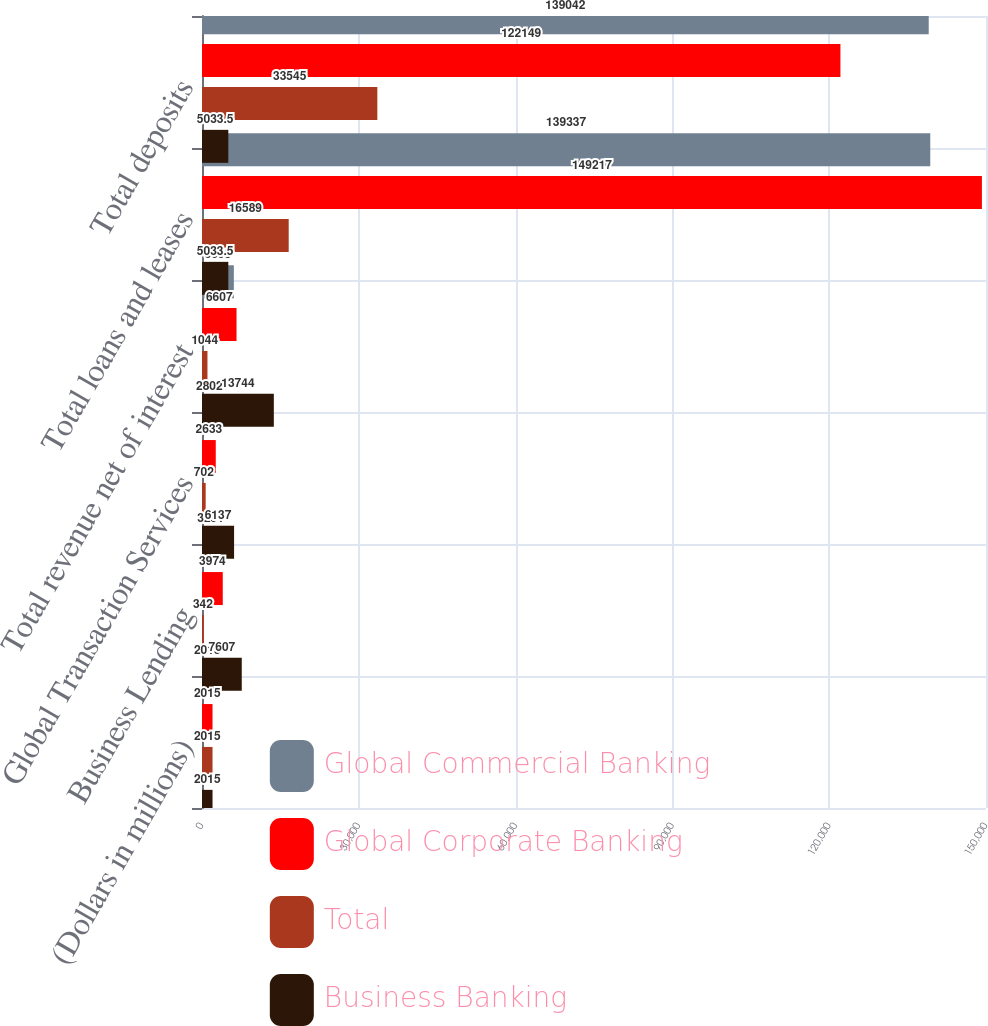<chart> <loc_0><loc_0><loc_500><loc_500><stacked_bar_chart><ecel><fcel>(Dollars in millions)<fcel>Business Lending<fcel>Global Transaction Services<fcel>Total revenue net of interest<fcel>Total loans and leases<fcel>Total deposits<nl><fcel>Global Commercial Banking<fcel>2015<fcel>3291<fcel>2802<fcel>6093<fcel>139337<fcel>139042<nl><fcel>Global Corporate Banking<fcel>2015<fcel>3974<fcel>2633<fcel>6607<fcel>149217<fcel>122149<nl><fcel>Total<fcel>2015<fcel>342<fcel>702<fcel>1044<fcel>16589<fcel>33545<nl><fcel>Business Banking<fcel>2015<fcel>7607<fcel>6137<fcel>13744<fcel>5033.5<fcel>5033.5<nl></chart> 